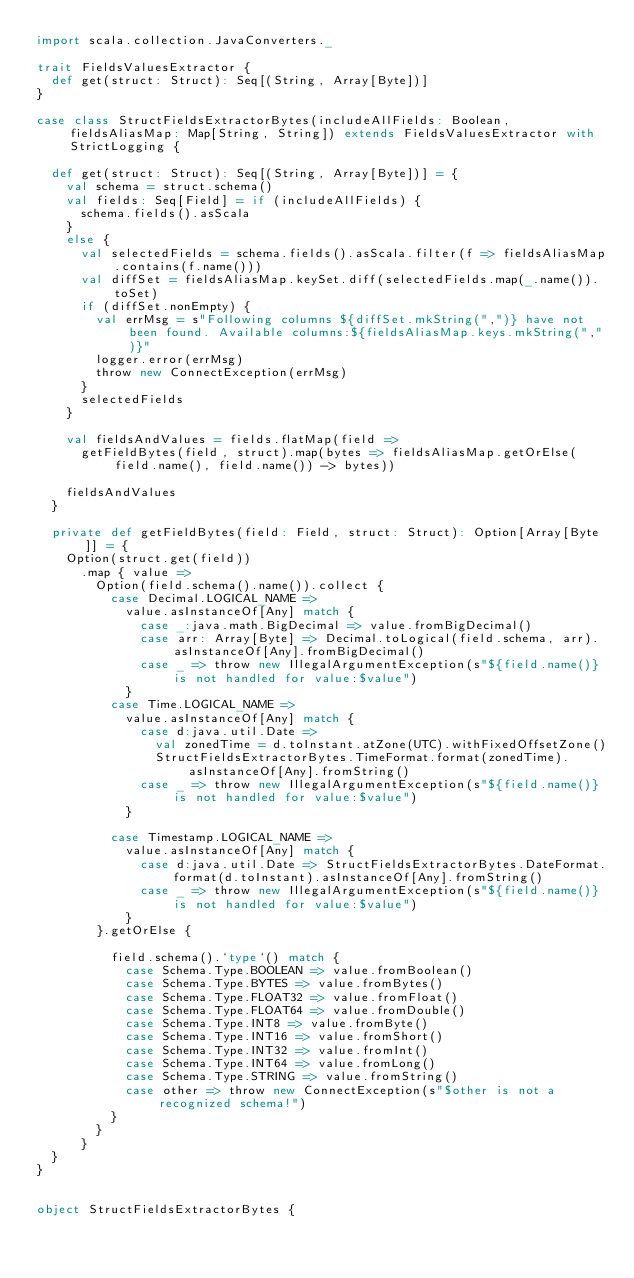Convert code to text. <code><loc_0><loc_0><loc_500><loc_500><_Scala_>import scala.collection.JavaConverters._

trait FieldsValuesExtractor {
  def get(struct: Struct): Seq[(String, Array[Byte])]
}

case class StructFieldsExtractorBytes(includeAllFields: Boolean, fieldsAliasMap: Map[String, String]) extends FieldsValuesExtractor with StrictLogging {

  def get(struct: Struct): Seq[(String, Array[Byte])] = {
    val schema = struct.schema()
    val fields: Seq[Field] = if (includeAllFields) {
      schema.fields().asScala
    }
    else {
      val selectedFields = schema.fields().asScala.filter(f => fieldsAliasMap.contains(f.name()))
      val diffSet = fieldsAliasMap.keySet.diff(selectedFields.map(_.name()).toSet)
      if (diffSet.nonEmpty) {
        val errMsg = s"Following columns ${diffSet.mkString(",")} have not been found. Available columns:${fieldsAliasMap.keys.mkString(",")}"
        logger.error(errMsg)
        throw new ConnectException(errMsg)
      }
      selectedFields
    }

    val fieldsAndValues = fields.flatMap(field =>
      getFieldBytes(field, struct).map(bytes => fieldsAliasMap.getOrElse(field.name(), field.name()) -> bytes))

    fieldsAndValues
  }

  private def getFieldBytes(field: Field, struct: Struct): Option[Array[Byte]] = {
    Option(struct.get(field))
      .map { value =>
        Option(field.schema().name()).collect {
          case Decimal.LOGICAL_NAME =>
            value.asInstanceOf[Any] match {
              case _:java.math.BigDecimal => value.fromBigDecimal()
              case arr: Array[Byte] => Decimal.toLogical(field.schema, arr).asInstanceOf[Any].fromBigDecimal()
              case _ => throw new IllegalArgumentException(s"${field.name()} is not handled for value:$value")
            }
          case Time.LOGICAL_NAME =>
            value.asInstanceOf[Any] match {
              case d:java.util.Date =>
                val zonedTime = d.toInstant.atZone(UTC).withFixedOffsetZone()
                StructFieldsExtractorBytes.TimeFormat.format(zonedTime).asInstanceOf[Any].fromString()
              case _ => throw new IllegalArgumentException(s"${field.name()} is not handled for value:$value")
            }

          case Timestamp.LOGICAL_NAME =>
            value.asInstanceOf[Any] match {
              case d:java.util.Date => StructFieldsExtractorBytes.DateFormat.format(d.toInstant).asInstanceOf[Any].fromString()
              case _ => throw new IllegalArgumentException(s"${field.name()} is not handled for value:$value")
            }
        }.getOrElse {

          field.schema().`type`() match {
            case Schema.Type.BOOLEAN => value.fromBoolean()
            case Schema.Type.BYTES => value.fromBytes()
            case Schema.Type.FLOAT32 => value.fromFloat()
            case Schema.Type.FLOAT64 => value.fromDouble()
            case Schema.Type.INT8 => value.fromByte()
            case Schema.Type.INT16 => value.fromShort()
            case Schema.Type.INT32 => value.fromInt()
            case Schema.Type.INT64 => value.fromLong()
            case Schema.Type.STRING => value.fromString()
            case other => throw new ConnectException(s"$other is not a recognized schema!")
          }
        }
      }
  }
}


object StructFieldsExtractorBytes {</code> 